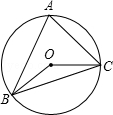Could you explain if the circle has any special properties because of the inscribed triangle? Certainly! The circle with inscribed triangle ABC obtains a few interesting properties from this configuration. Most notably, all angles of the triangle at the circumference are related to the central angles, as any inscribed angle is exactly half of the central angle subtending the same arc. Additionally, since the sum of the angles in triangle ABC must equal 180 degrees, and one of the angles is given as 60 degrees, this imposes limits on the possible measures of the other two angles, thus interlinking the entire system in a dance of geometric dependency. 